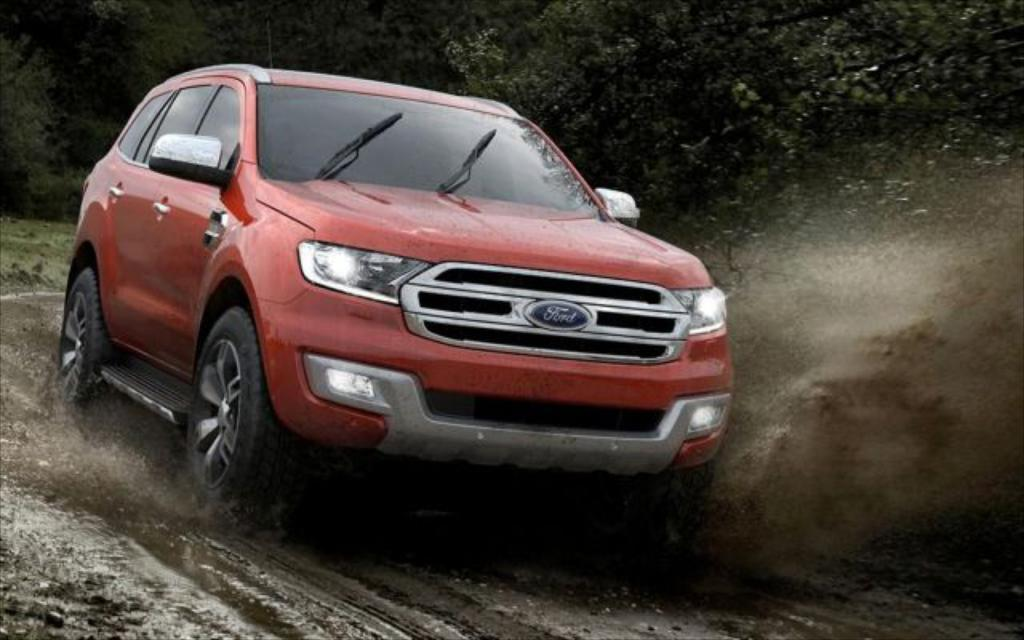What is the main subject of the image? There is a car on the road in the image. What is the condition of the road in the image? The road has mud and water on it in the image. What can be seen in the background of the image? There are trees visible in the background of the image. What type of bedroom can be seen in the image? There is no bedroom present in the image; it features a car on a muddy and wet road with trees in the background. 